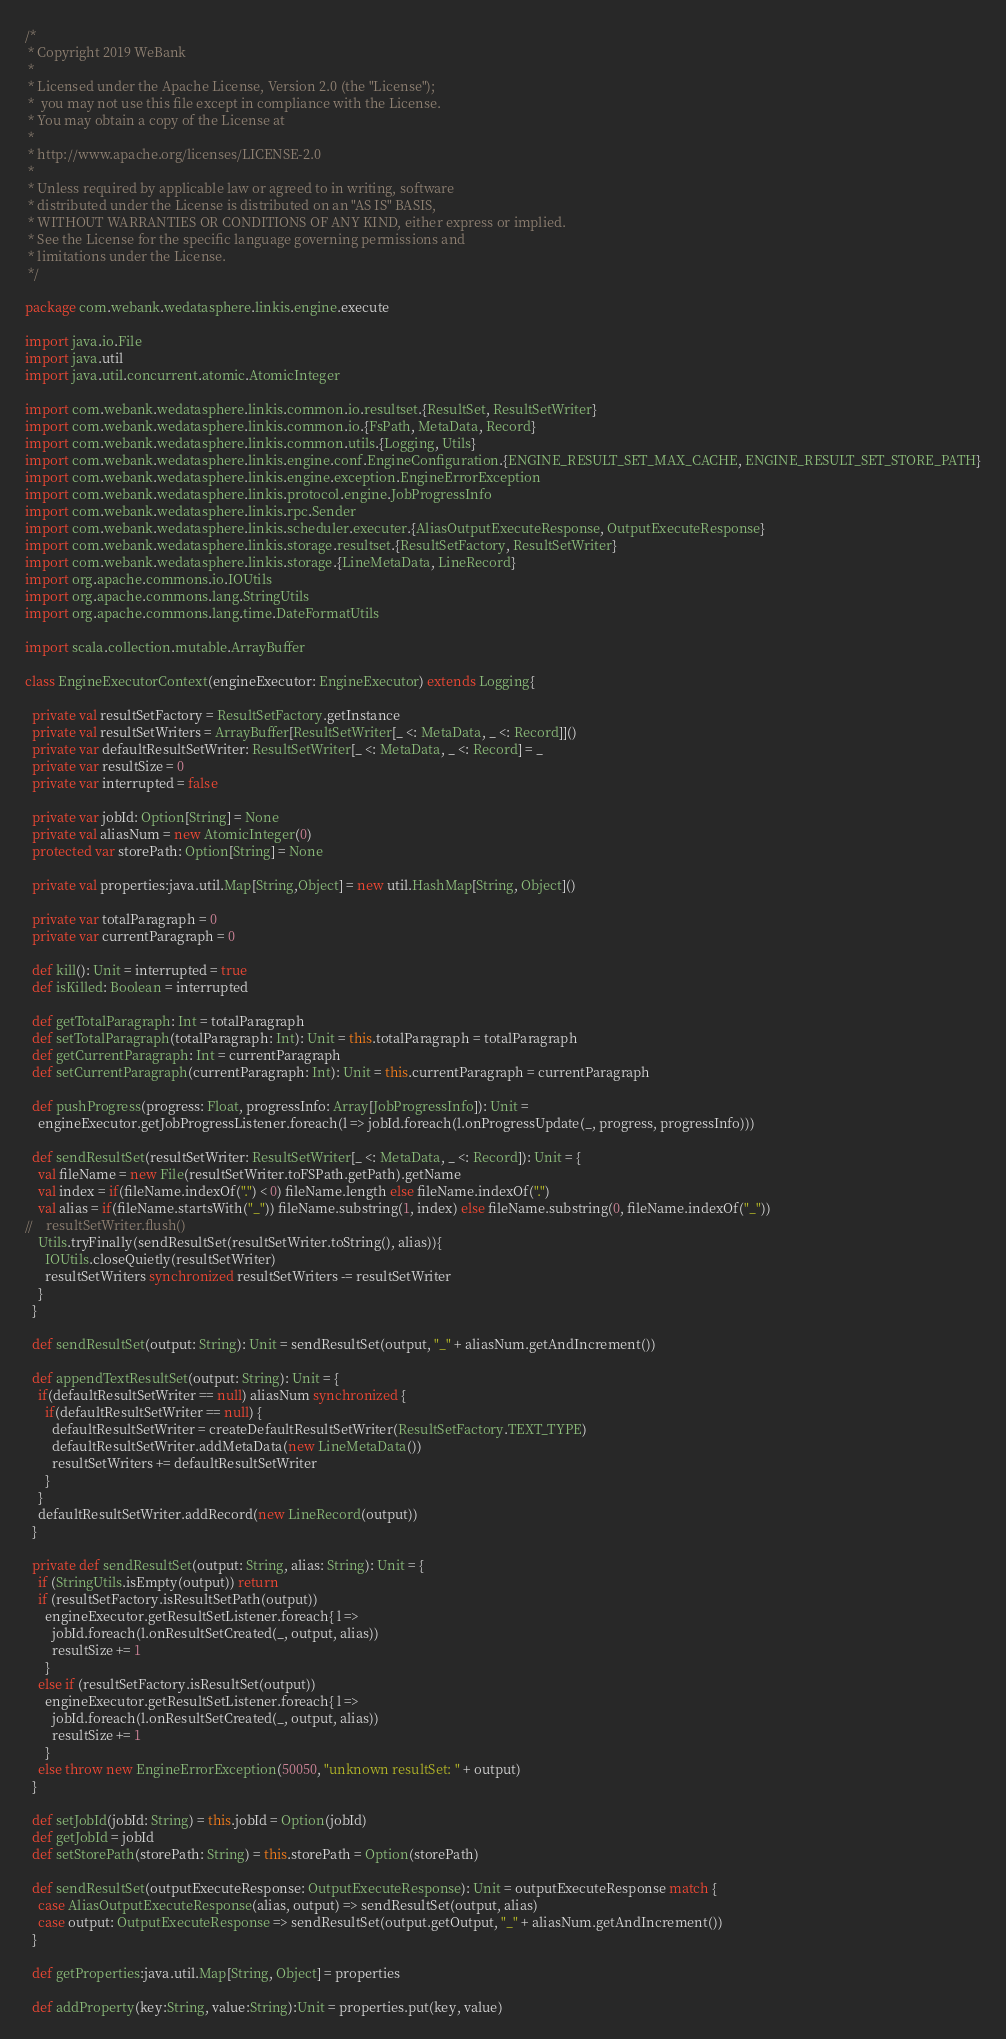<code> <loc_0><loc_0><loc_500><loc_500><_Scala_>/*
 * Copyright 2019 WeBank
 *
 * Licensed under the Apache License, Version 2.0 (the "License");
 *  you may not use this file except in compliance with the License.
 * You may obtain a copy of the License at
 *
 * http://www.apache.org/licenses/LICENSE-2.0
 *
 * Unless required by applicable law or agreed to in writing, software
 * distributed under the License is distributed on an "AS IS" BASIS,
 * WITHOUT WARRANTIES OR CONDITIONS OF ANY KIND, either express or implied.
 * See the License for the specific language governing permissions and
 * limitations under the License.
 */

package com.webank.wedatasphere.linkis.engine.execute

import java.io.File
import java.util
import java.util.concurrent.atomic.AtomicInteger

import com.webank.wedatasphere.linkis.common.io.resultset.{ResultSet, ResultSetWriter}
import com.webank.wedatasphere.linkis.common.io.{FsPath, MetaData, Record}
import com.webank.wedatasphere.linkis.common.utils.{Logging, Utils}
import com.webank.wedatasphere.linkis.engine.conf.EngineConfiguration.{ENGINE_RESULT_SET_MAX_CACHE, ENGINE_RESULT_SET_STORE_PATH}
import com.webank.wedatasphere.linkis.engine.exception.EngineErrorException
import com.webank.wedatasphere.linkis.protocol.engine.JobProgressInfo
import com.webank.wedatasphere.linkis.rpc.Sender
import com.webank.wedatasphere.linkis.scheduler.executer.{AliasOutputExecuteResponse, OutputExecuteResponse}
import com.webank.wedatasphere.linkis.storage.resultset.{ResultSetFactory, ResultSetWriter}
import com.webank.wedatasphere.linkis.storage.{LineMetaData, LineRecord}
import org.apache.commons.io.IOUtils
import org.apache.commons.lang.StringUtils
import org.apache.commons.lang.time.DateFormatUtils

import scala.collection.mutable.ArrayBuffer

class EngineExecutorContext(engineExecutor: EngineExecutor) extends Logging{

  private val resultSetFactory = ResultSetFactory.getInstance
  private val resultSetWriters = ArrayBuffer[ResultSetWriter[_ <: MetaData, _ <: Record]]()
  private var defaultResultSetWriter: ResultSetWriter[_ <: MetaData, _ <: Record] = _
  private var resultSize = 0
  private var interrupted = false

  private var jobId: Option[String] = None
  private val aliasNum = new AtomicInteger(0)
  protected var storePath: Option[String] = None

  private val properties:java.util.Map[String,Object] = new util.HashMap[String, Object]()

  private var totalParagraph = 0
  private var currentParagraph = 0

  def kill(): Unit = interrupted = true
  def isKilled: Boolean = interrupted

  def getTotalParagraph: Int = totalParagraph
  def setTotalParagraph(totalParagraph: Int): Unit = this.totalParagraph = totalParagraph
  def getCurrentParagraph: Int = currentParagraph
  def setCurrentParagraph(currentParagraph: Int): Unit = this.currentParagraph = currentParagraph

  def pushProgress(progress: Float, progressInfo: Array[JobProgressInfo]): Unit =
    engineExecutor.getJobProgressListener.foreach(l => jobId.foreach(l.onProgressUpdate(_, progress, progressInfo)))

  def sendResultSet(resultSetWriter: ResultSetWriter[_ <: MetaData, _ <: Record]): Unit = {
    val fileName = new File(resultSetWriter.toFSPath.getPath).getName
    val index = if(fileName.indexOf(".") < 0) fileName.length else fileName.indexOf(".")
    val alias = if(fileName.startsWith("_")) fileName.substring(1, index) else fileName.substring(0, fileName.indexOf("_"))
//    resultSetWriter.flush()
    Utils.tryFinally(sendResultSet(resultSetWriter.toString(), alias)){
      IOUtils.closeQuietly(resultSetWriter)
      resultSetWriters synchronized resultSetWriters -= resultSetWriter
    }
  }

  def sendResultSet(output: String): Unit = sendResultSet(output, "_" + aliasNum.getAndIncrement())

  def appendTextResultSet(output: String): Unit = {
    if(defaultResultSetWriter == null) aliasNum synchronized {
      if(defaultResultSetWriter == null) {
        defaultResultSetWriter = createDefaultResultSetWriter(ResultSetFactory.TEXT_TYPE)
        defaultResultSetWriter.addMetaData(new LineMetaData())
        resultSetWriters += defaultResultSetWriter
      }
    }
    defaultResultSetWriter.addRecord(new LineRecord(output))
  }

  private def sendResultSet(output: String, alias: String): Unit = {
    if (StringUtils.isEmpty(output)) return
    if (resultSetFactory.isResultSetPath(output))
      engineExecutor.getResultSetListener.foreach{ l =>
        jobId.foreach(l.onResultSetCreated(_, output, alias))
        resultSize += 1
      }
    else if (resultSetFactory.isResultSet(output))
      engineExecutor.getResultSetListener.foreach{ l =>
        jobId.foreach(l.onResultSetCreated(_, output, alias))
        resultSize += 1
      }
    else throw new EngineErrorException(50050, "unknown resultSet: " + output)
  }

  def setJobId(jobId: String) = this.jobId = Option(jobId)
  def getJobId = jobId
  def setStorePath(storePath: String) = this.storePath = Option(storePath)

  def sendResultSet(outputExecuteResponse: OutputExecuteResponse): Unit = outputExecuteResponse match {
    case AliasOutputExecuteResponse(alias, output) => sendResultSet(output, alias)
    case output: OutputExecuteResponse => sendResultSet(output.getOutput, "_" + aliasNum.getAndIncrement())
  }

  def getProperties:java.util.Map[String, Object] = properties

  def addProperty(key:String, value:String):Unit = properties.put(key, value)
</code> 